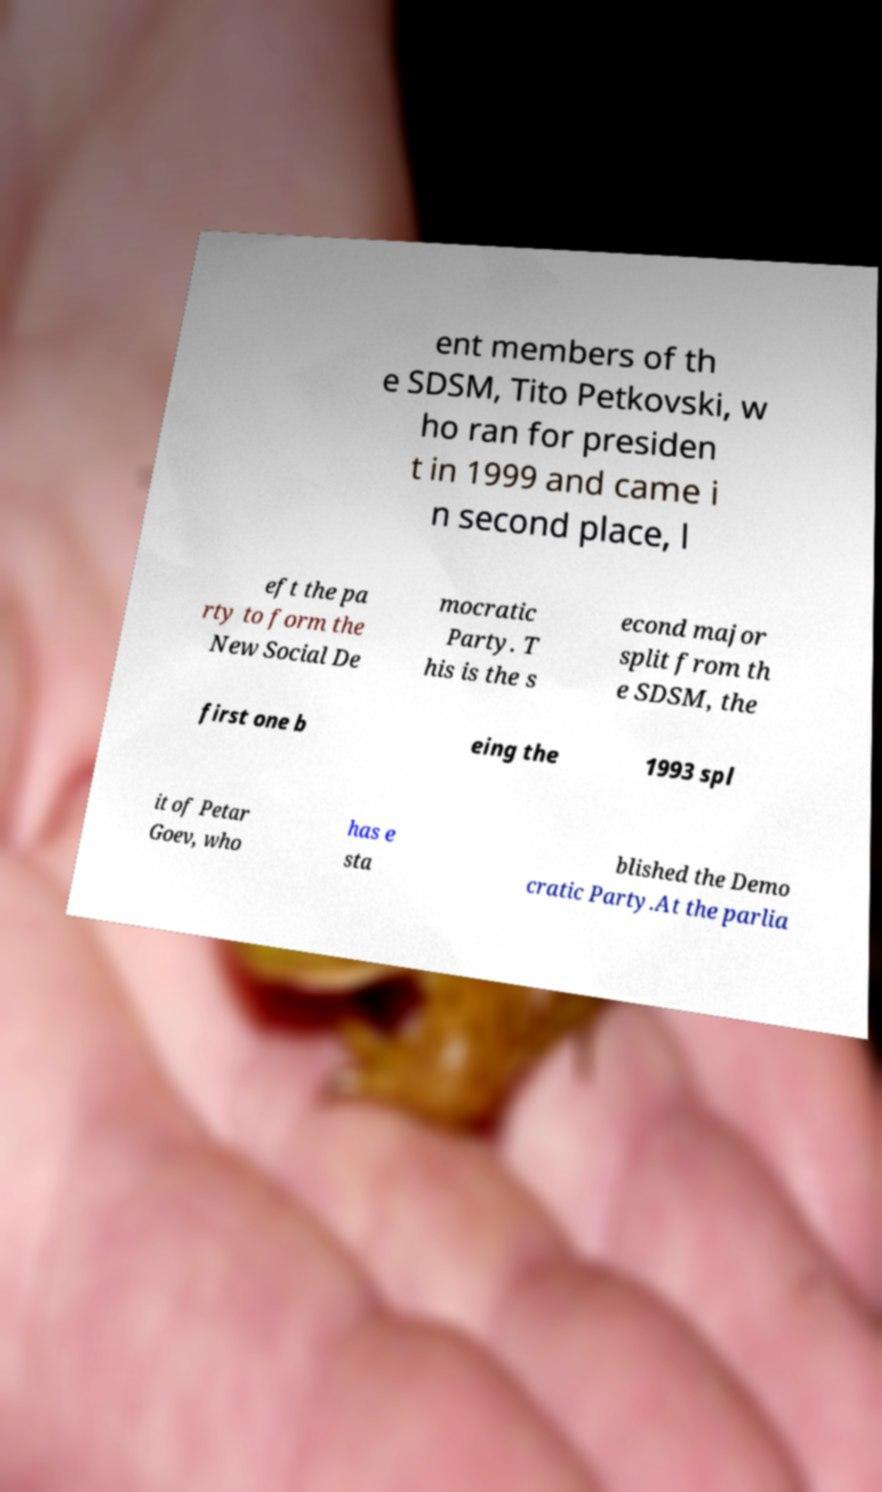Could you extract and type out the text from this image? ent members of th e SDSM, Tito Petkovski, w ho ran for presiden t in 1999 and came i n second place, l eft the pa rty to form the New Social De mocratic Party. T his is the s econd major split from th e SDSM, the first one b eing the 1993 spl it of Petar Goev, who has e sta blished the Demo cratic Party.At the parlia 